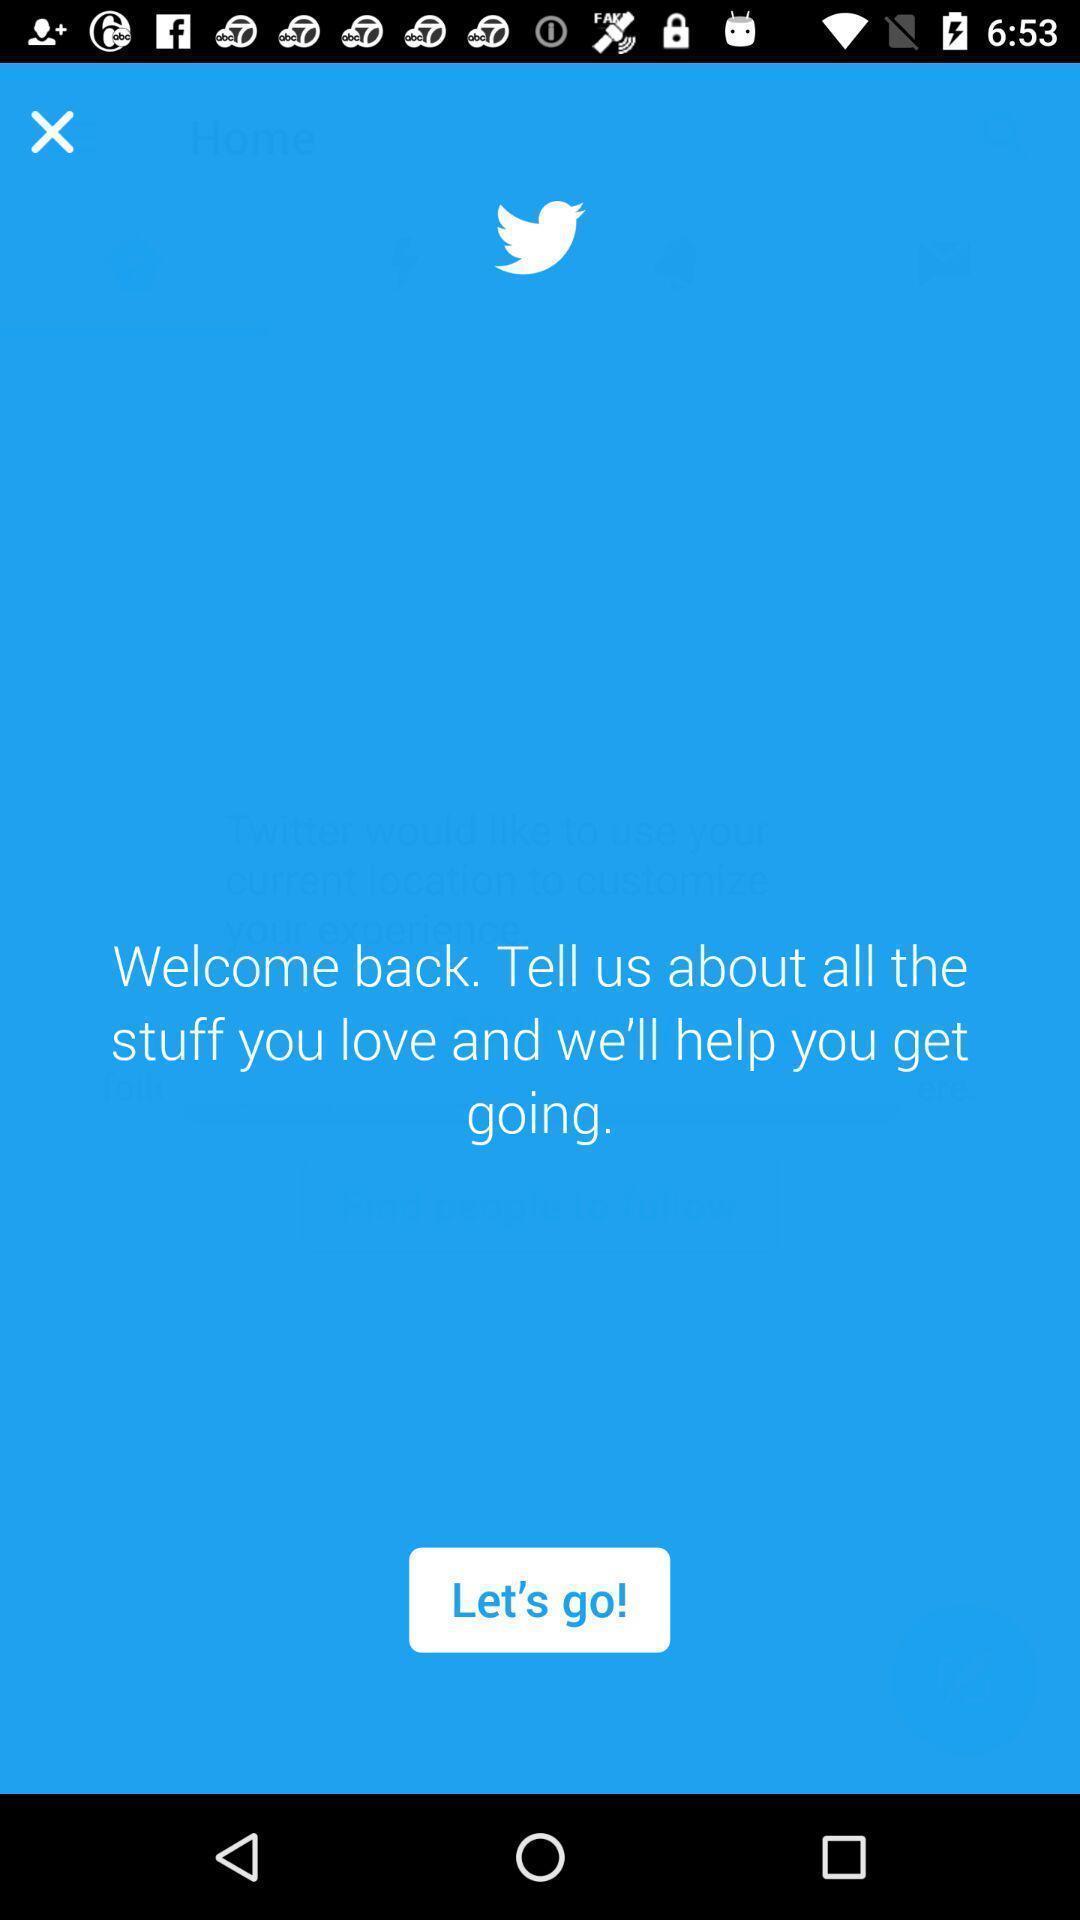Describe the key features of this screenshot. Welcome page of a social app. 